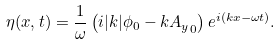<formula> <loc_0><loc_0><loc_500><loc_500>\eta ( x , t ) = \frac { 1 } { \omega } \left ( i | k | \phi _ { 0 } - k { A _ { y } } _ { 0 } \right ) e ^ { i ( k x - \omega t ) } .</formula> 